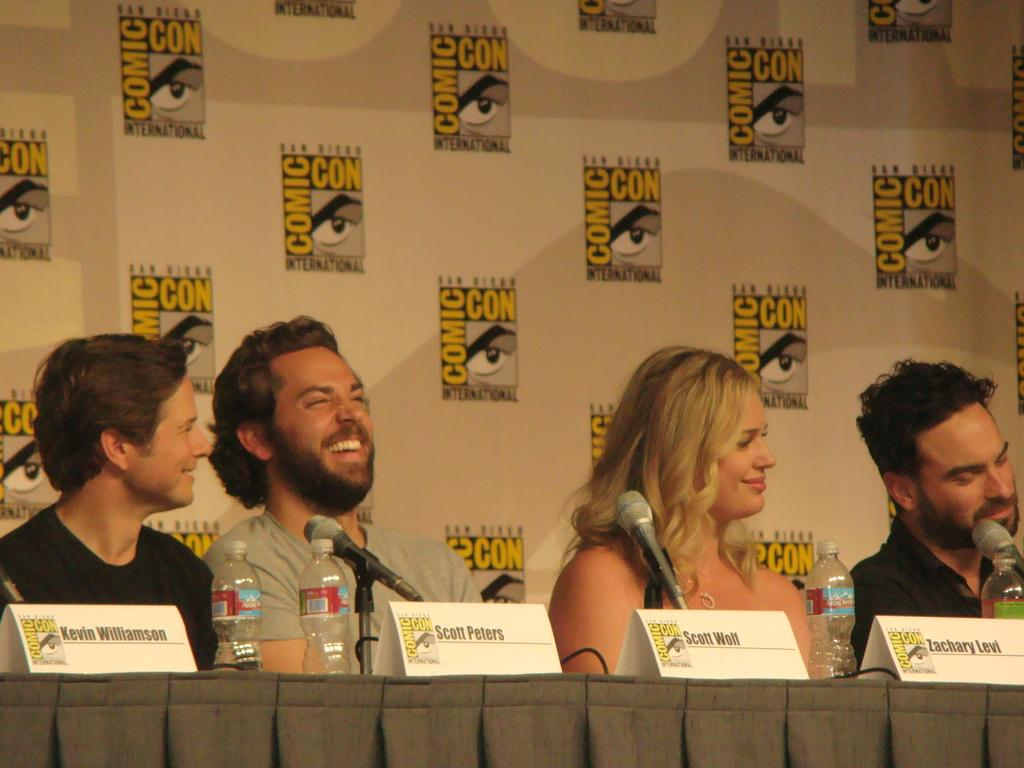How many people are sitting in the image? There are four persons sitting in the image. What objects are on the table in front of the people? There are microphones (mikes) and bottles on the table. Are there any labels or identifiers on the table? Yes, there are nameplates on the table. What can be seen in the background of the image? There is a board in the background of the image. How many planes are flying over the board in the background? There are no planes visible in the image, so it is not possible to determine how many planes might be flying over the board. Is there a ring on any of the person's fingers in the image? There is no ring visible on any of the person's fingers in the image. 